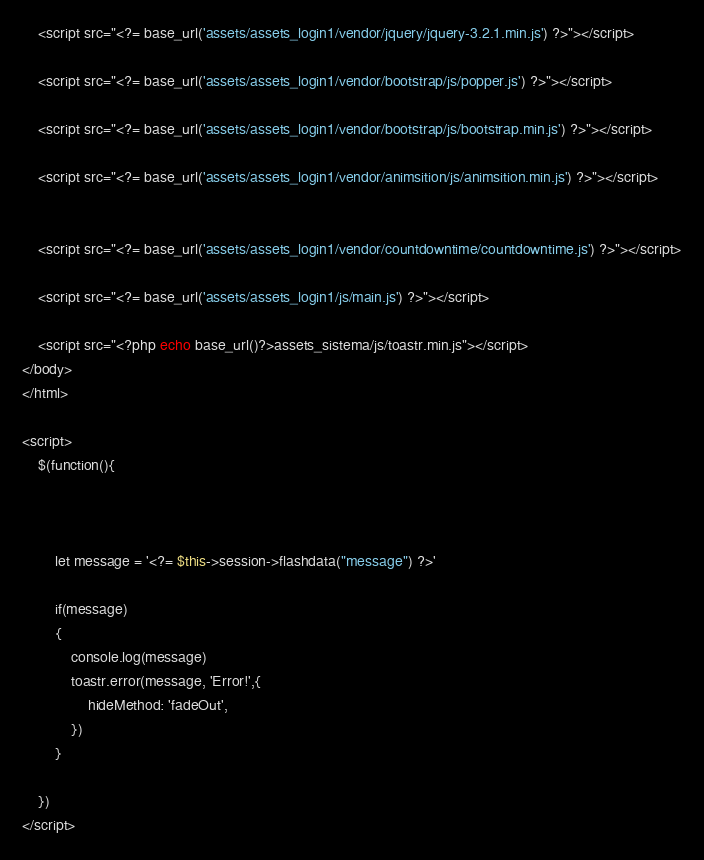Convert code to text. <code><loc_0><loc_0><loc_500><loc_500><_PHP_> 	<script src="<?= base_url('assets/assets_login1/vendor/jquery/jquery-3.2.1.min.js') ?>"></script>

   	<script src="<?= base_url('assets/assets_login1/vendor/bootstrap/js/popper.js') ?>"></script>
  	
  	<script src="<?= base_url('assets/assets_login1/vendor/bootstrap/js/bootstrap.min.js') ?>"></script>

   	<script src="<?= base_url('assets/assets_login1/vendor/animsition/js/animsition.min.js') ?>"></script>


 	<script src="<?= base_url('assets/assets_login1/vendor/countdowntime/countdowntime.js') ?>"></script>

  	<script src="<?= base_url('assets/assets_login1/js/main.js') ?>"></script>

  	<script src="<?php echo base_url()?>assets_sistema/js/toastr.min.js"></script>
</body>
</html>

<script>
	$(function(){

		
		
		let message = '<?= $this->session->flashdata("message") ?>'

		if(message)
		{
			console.log(message)
			toastr.error(message, 'Error!',{
				hideMethod: 'fadeOut',
			})
		}
			
	})
</script></code> 